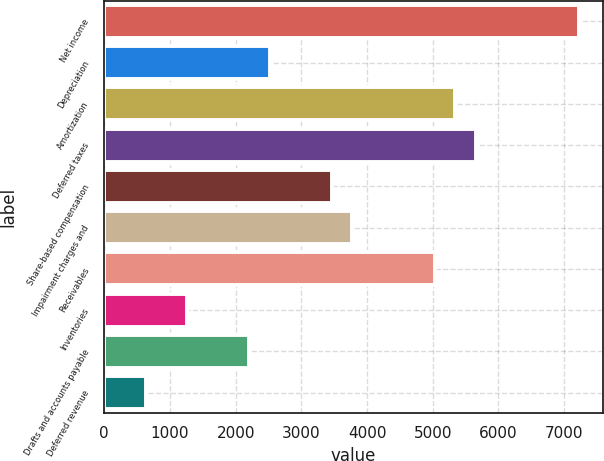Convert chart. <chart><loc_0><loc_0><loc_500><loc_500><bar_chart><fcel>Net income<fcel>Depreciation<fcel>Amortization<fcel>Deferred taxes<fcel>Share-based compensation<fcel>Impairment charges and<fcel>Receivables<fcel>Inventories<fcel>Drafts and accounts payable<fcel>Deferred revenue<nl><fcel>7228.4<fcel>2521.4<fcel>5345.6<fcel>5659.4<fcel>3462.8<fcel>3776.6<fcel>5031.8<fcel>1266.2<fcel>2207.6<fcel>638.6<nl></chart> 